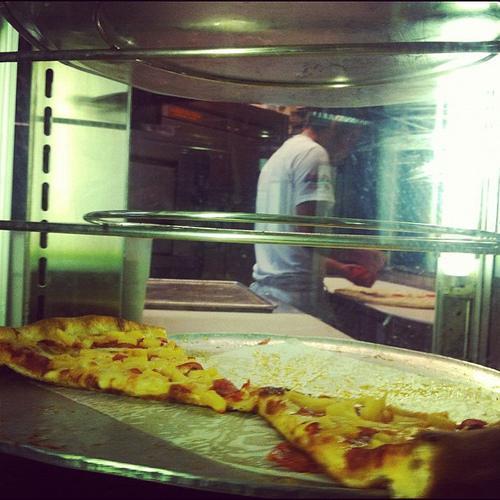How many slices of pizza are shown?
Give a very brief answer. 2. 